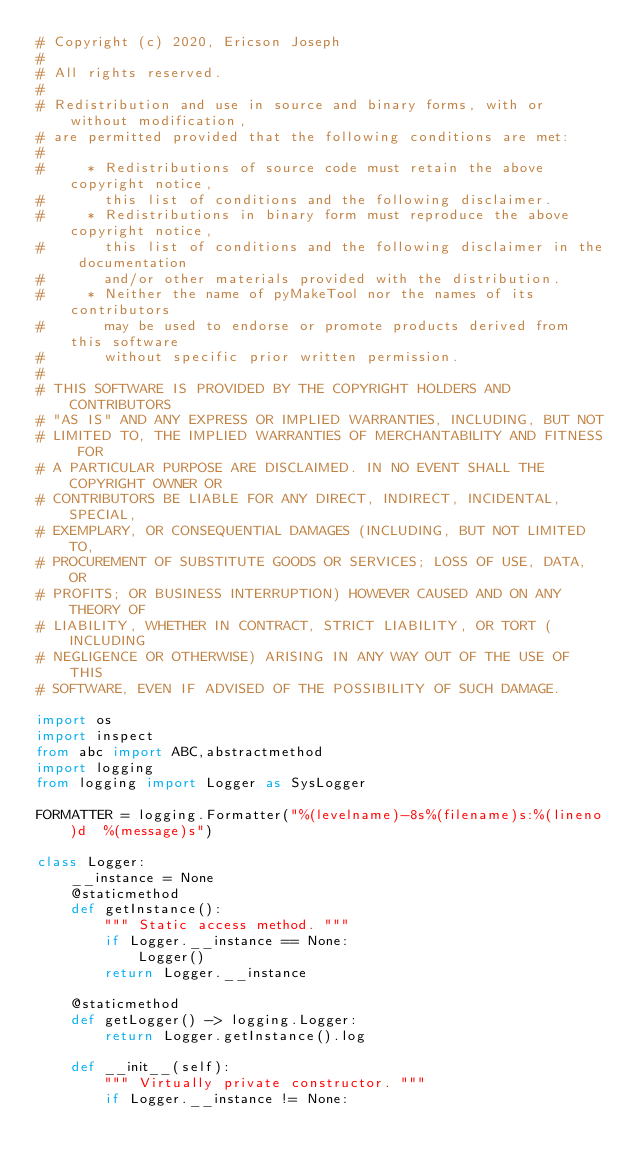<code> <loc_0><loc_0><loc_500><loc_500><_Python_># Copyright (c) 2020, Ericson Joseph
# 
# All rights reserved.
# 
# Redistribution and use in source and binary forms, with or without modification,
# are permitted provided that the following conditions are met:
# 
#     * Redistributions of source code must retain the above copyright notice,
#       this list of conditions and the following disclaimer.
#     * Redistributions in binary form must reproduce the above copyright notice,
#       this list of conditions and the following disclaimer in the documentation
#       and/or other materials provided with the distribution.
#     * Neither the name of pyMakeTool nor the names of its contributors
#       may be used to endorse or promote products derived from this software
#       without specific prior written permission.
# 
# THIS SOFTWARE IS PROVIDED BY THE COPYRIGHT HOLDERS AND CONTRIBUTORS
# "AS IS" AND ANY EXPRESS OR IMPLIED WARRANTIES, INCLUDING, BUT NOT
# LIMITED TO, THE IMPLIED WARRANTIES OF MERCHANTABILITY AND FITNESS FOR
# A PARTICULAR PURPOSE ARE DISCLAIMED. IN NO EVENT SHALL THE COPYRIGHT OWNER OR
# CONTRIBUTORS BE LIABLE FOR ANY DIRECT, INDIRECT, INCIDENTAL, SPECIAL,
# EXEMPLARY, OR CONSEQUENTIAL DAMAGES (INCLUDING, BUT NOT LIMITED TO,
# PROCUREMENT OF SUBSTITUTE GOODS OR SERVICES; LOSS OF USE, DATA, OR
# PROFITS; OR BUSINESS INTERRUPTION) HOWEVER CAUSED AND ON ANY THEORY OF
# LIABILITY, WHETHER IN CONTRACT, STRICT LIABILITY, OR TORT (INCLUDING
# NEGLIGENCE OR OTHERWISE) ARISING IN ANY WAY OUT OF THE USE OF THIS
# SOFTWARE, EVEN IF ADVISED OF THE POSSIBILITY OF SUCH DAMAGE.

import os
import inspect
from abc import ABC,abstractmethod
import logging
from logging import Logger as SysLogger

FORMATTER = logging.Formatter("%(levelname)-8s%(filename)s:%(lineno)d  %(message)s")

class Logger:
    __instance = None
    @staticmethod
    def getInstance():
        """ Static access method. """
        if Logger.__instance == None:
            Logger()
        return Logger.__instance

    @staticmethod
    def getLogger() -> logging.Logger:
        return Logger.getInstance().log

    def __init__(self):
        """ Virtually private constructor. """
        if Logger.__instance != None:</code> 